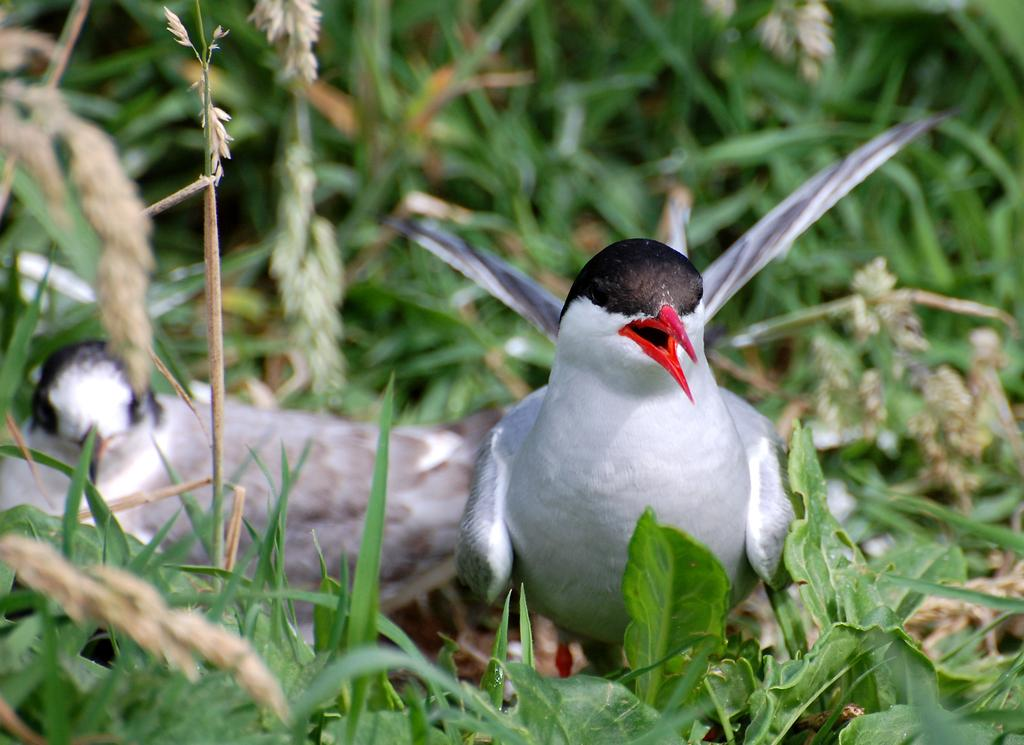What type of animals can be seen in the image? There are two white birds in the image. Where are the birds located? The birds are on the ground. What type of vegetation is visible in the image? There is grass visible in the image. Can you describe the background of the image? The background of the image is slightly blurred, and there are plants visible. What type of minute can be seen in the image? There is no mention of a minute in the image, as it features two white birds on the ground with grass and a blurred background. 